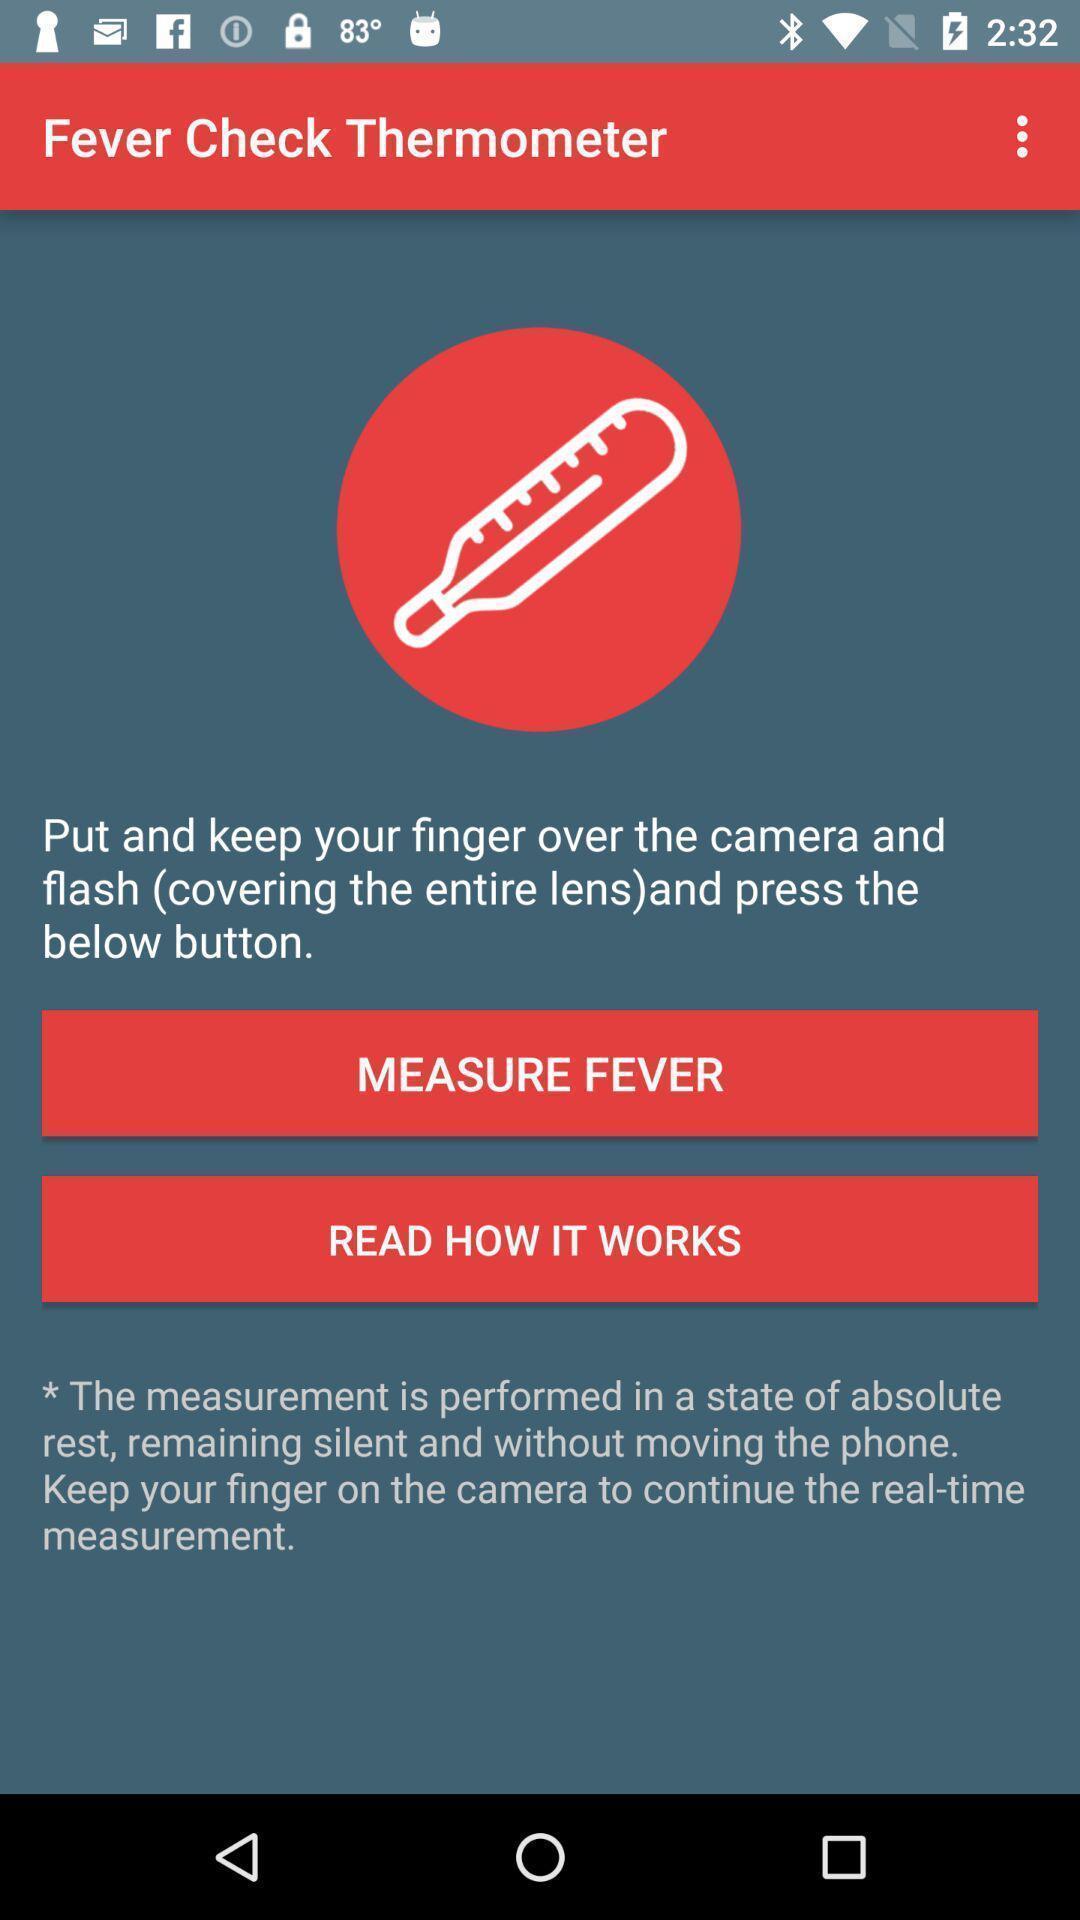What is the overall content of this screenshot? Page to check the fever and in details. 